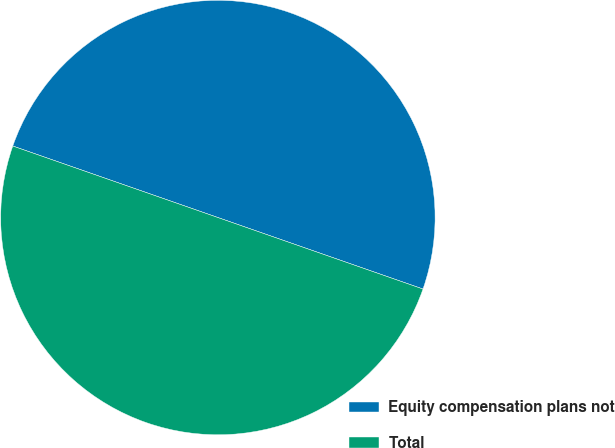<chart> <loc_0><loc_0><loc_500><loc_500><pie_chart><fcel>Equity compensation plans not<fcel>Total<nl><fcel>50.0%<fcel>50.0%<nl></chart> 